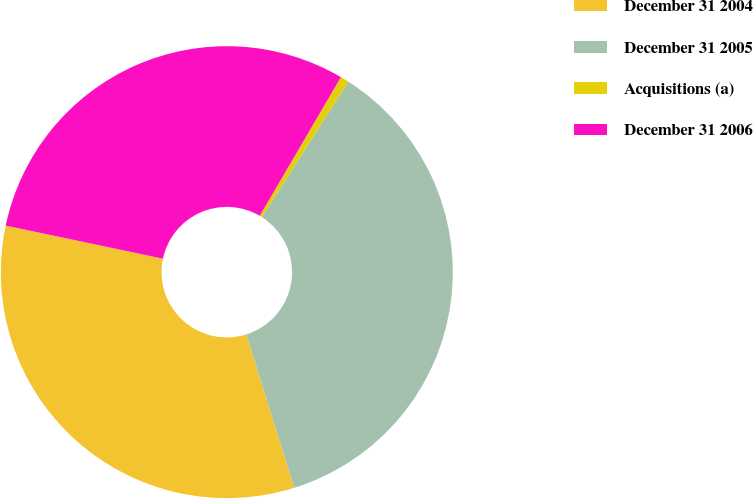Convert chart to OTSL. <chart><loc_0><loc_0><loc_500><loc_500><pie_chart><fcel>December 31 2004<fcel>December 31 2005<fcel>Acquisitions (a)<fcel>December 31 2006<nl><fcel>33.13%<fcel>36.14%<fcel>0.61%<fcel>30.12%<nl></chart> 